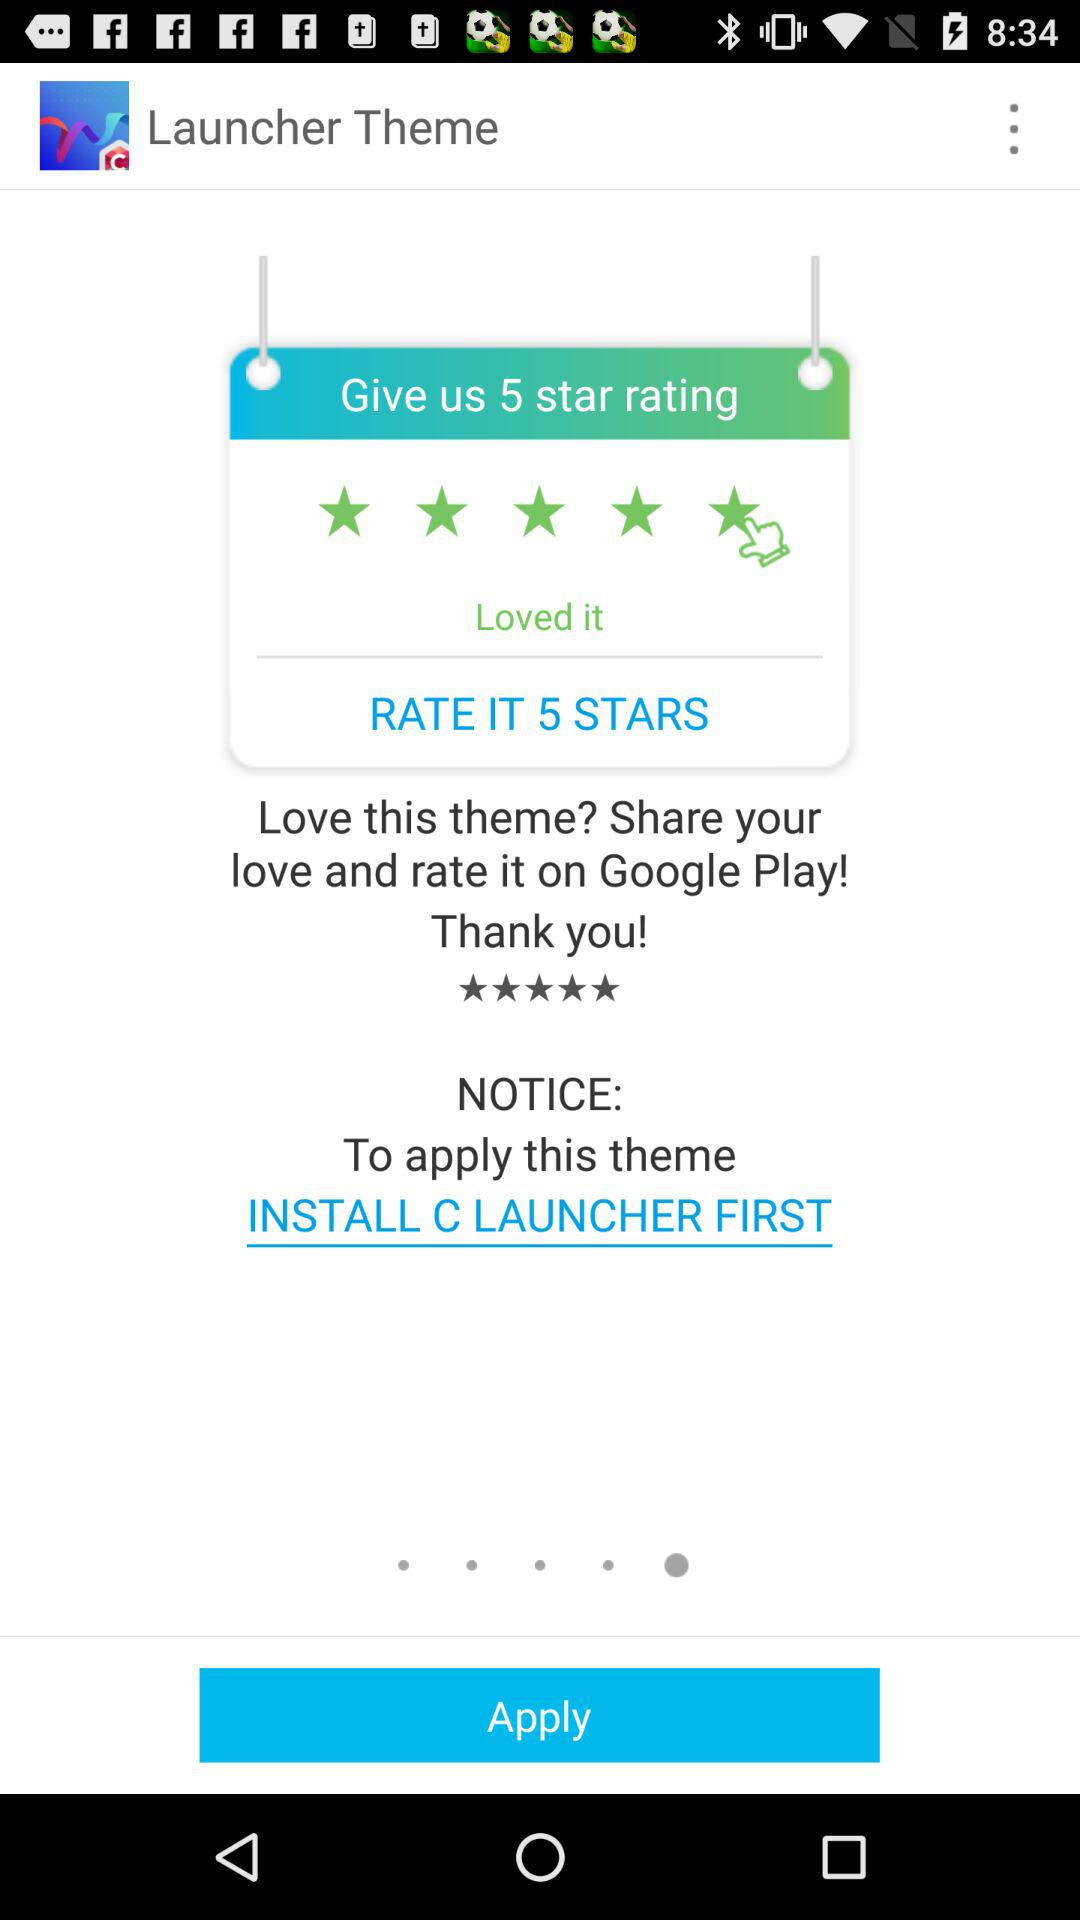What should be done to apply this theme? To apply this theme, install "C LAUNCHER" first. 